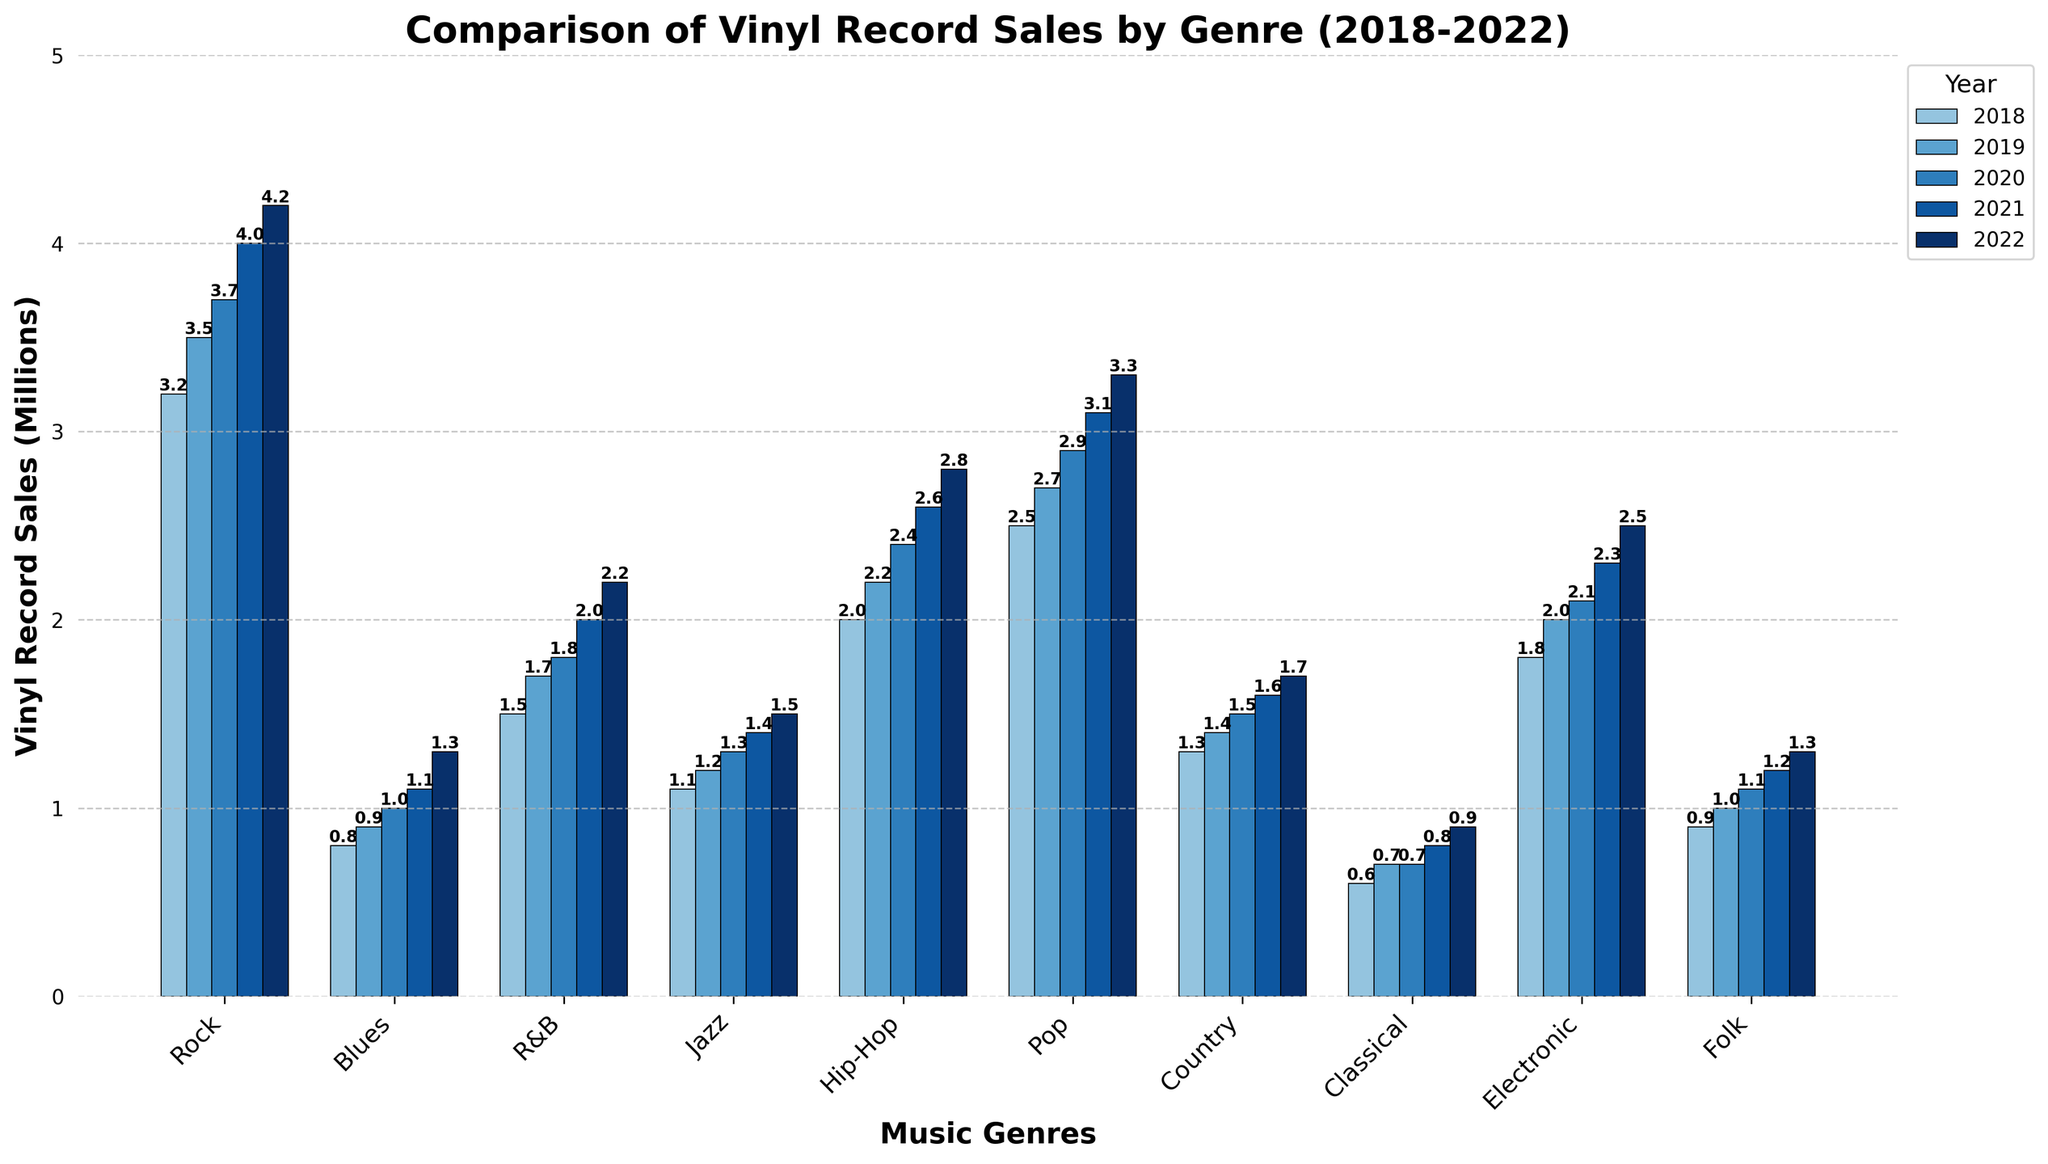Which genre saw the highest growth in vinyl record sales from 2018 to 2022? Look at the difference in sales from 2018 to 2022 for each genre. Rock increased by 4.2 - 3.2 = 1.0 million, Blues by 1.3 - 0.8 = 0.5 million, R&B by 2.2 - 1.5 = 0.7 million, Jazz by 1.5 - 1.1 = 0.4 million, Hip-Hop by 2.8 - 2.0 = 0.8 million, Pop by 3.3 - 2.5 = 0.8 million, Country by 1.7 - 1.3 = 0.4 million, Classical by 0.9 - 0.6 = 0.3 million, Electronic by 2.5 - 1.8 = 0.7 million, and Folk by 1.3 - 0.9 = 0.4 million. Rock showed the highest growth with a 1.0 million sales increase.
Answer: Rock Which genre had the lowest vinyl record sales in 2022? Look at the vinyl record sales values for 2022 across all genres. The values are Rock 4.2, Blues 1.3, R&B 2.2, Jazz 1.5, Hip-Hop 2.8, Pop 3.3, Country 1.7, Classical 0.9, Electronic 2.5, and Folk 1.3. Classical has the lowest sales at 0.9 million.
Answer: Classical Between which two consecutive years did Blues see the greatest increase in vinyl record sales? Calculate the differences for Blues between consecutive years: 2019-2018 (0.9-0.8 = 0.1), 2020-2019 (1.0-0.9 = 0.1), 2021-2020 (1.1-1.0 = 0.1), 2022-2021 (1.3-1.1 = 0.2). The greatest increase was between 2021 and 2022, with an increase of 0.2 million.
Answer: 2021 and 2022 How do the vinyl record sales of Rock compare to that of Pop in 2021? Look at the sales values for Rock and Pop in the year 2021. Rock had sales of 4.0 million, while Pop had 3.1 million. Rock sales are higher than Pop sales.
Answer: Rock sales are higher What was the total vinyl record sales for Hip-Hop over the 5-year period? Sum the vinyl record sales for Hip-Hop from 2018 to 2022: 2.0 + 2.2 + 2.4 + 2.6 + 2.8 = 12.0 million. The total sales are 12.0 million.
Answer: 12.0 million What is the average yearly sales of Electronic from 2018 to 2022? Calculate the average by summing the sales and dividing by the number of years: (1.8 + 2.0 + 2.1 + 2.3 + 2.5) / 5 = 10.7 / 5 = 2.14 million. The average yearly sales are 2.14 million.
Answer: 2.14 million Which genre had consistently increasing sales every year? Check each genre to see if their sales increased each year: Rock (yes), Blues (yes), R&B (yes), Jazz (yes), Hip-Hop (yes), Pop (yes), Country (yes), Classical (yes), Electronic (yes), Folk (yes). All genres had consistently increasing sales every year.
Answer: All genres Which genre had the highest sales in 2020? Look at the sales values for all genres in 2020. Rock had 3.7 million, Blues had 1.0 million, R&B had 1.8 million, Jazz had 1.3 million, Hip-Hop had 2.4 million, Pop had 2.9 million, Country had 1.5 million, Classical had 0.7 million, Electronic had 2.1 million, Folk had 1.1 million. Rock had the highest sales at 3.7 million.
Answer: Rock 